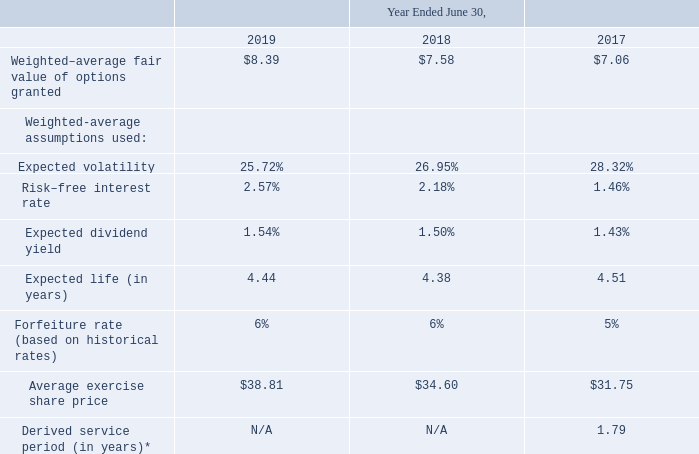For the periods indicated, the weighted-average fair value of options and weighted-average assumptions were as follows:
*Options valued using Monte Carlo Valuation Method
As of June 30, 2019, the total compensation cost related to the unvested stock option awards not yet recognized was approximately $24.1 million, which will be recognized over a weighted-average period of approximately 3.0 years.
No cash was used by us to settle equity instruments granted under share-based compensation arrangements in any of the periods presented.
We have not capitalized any share-based compensation costs as part of the cost of an asset in any of the periods presented.
For the year ended June 30, 2019, cash in the amount of $35.6 million was received as the result of the exercise of options granted under share-based payment arrangements. The tax benefit realized by us during the year ended June 30, 2019 from the exercise of options eligible for a tax deduction was $2.9 million.
For the year ended June 30, 2018, cash in the amount of $54.4 million was received as the result of the exercise of options granted under share-based payment arrangements. The tax benefit realized by us during the year ended June 30, 2018 from the exercise of options eligible for a tax deduction was $1.5 million.
For the year ended June 30, 2017, cash in the amount of $20.8 million was received as the result of the exercise of options granted under share-based payment arrangements. The tax benefit realized by us during the year ended June 30, 2017 from the exercise of options eligible for a tax deduction was $2.2 million.
How was the derived service period calculated? Using monte carlo valuation method. How much was the tax benefit realised by the company during the year ended June 30, 2019? $1.5 million. What does the table show? Weighted-average fair value of options and weighted-average assumptions. What are the Fiscal years, sorted in ascending order of Risk–free interest rate? For rows 6 sort in ascending order the percentages of Risk–free interest rate.
Answer: 2017, 2018, 2019. What is the average annual expected dividend yield?
Answer scale should be: percent. (1.54+1.50+1.43)/3
Answer: 1.49. What is the total tax benefit for fiscal years 2017-2019?
Answer scale should be: million. 2.9+1.5+2.2
Answer: 6.6. 